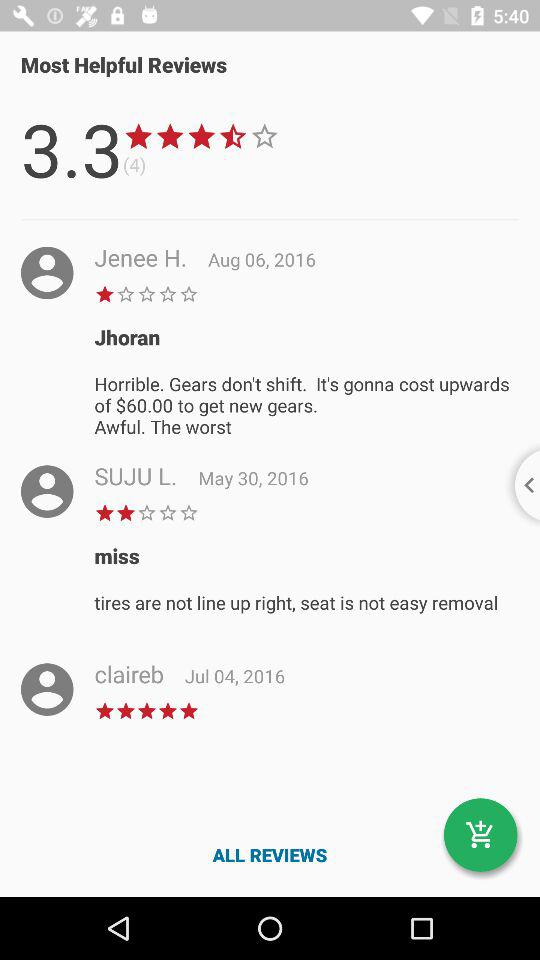When Claireb wrote the review? Claireb wrote the review on July 4, 2016. 